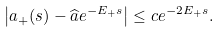Convert formula to latex. <formula><loc_0><loc_0><loc_500><loc_500>\left | a _ { + } ( s ) - \widehat { a } e ^ { - E _ { + } s } \right | \leq c e ^ { - 2 E _ { + } s } .</formula> 